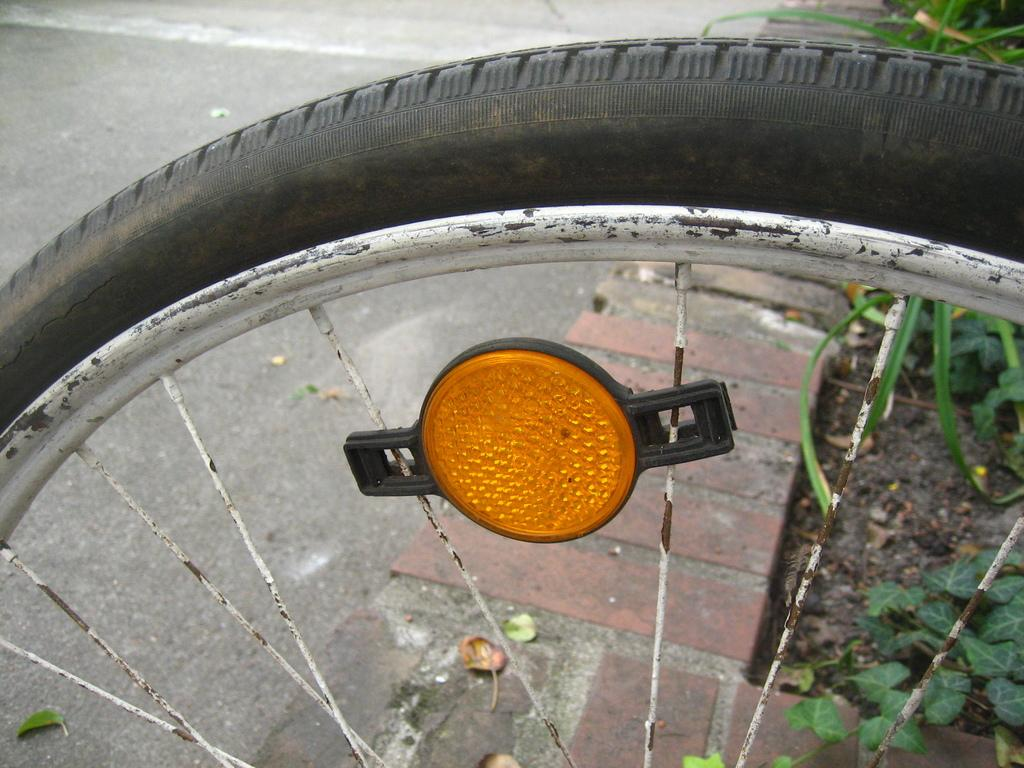What is the main object in the image? There is a tire with rims in the image. Can you describe any other objects in the image? There is a light in the image. What can be seen in the background of the image? There are plants and a brick wall in the background of the image. How many matches does the expert hold in the image? There are no matches or experts present in the image. 